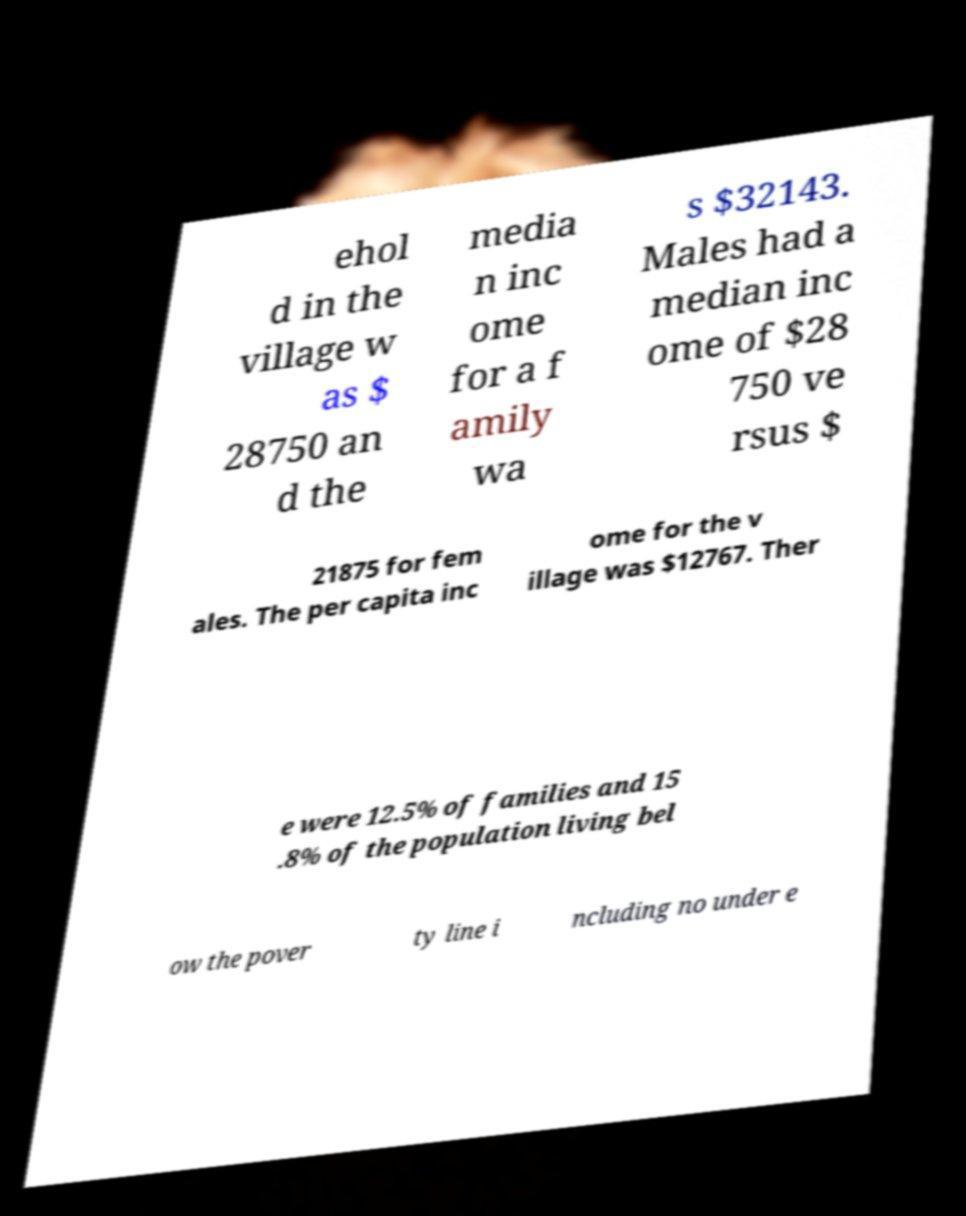There's text embedded in this image that I need extracted. Can you transcribe it verbatim? ehol d in the village w as $ 28750 an d the media n inc ome for a f amily wa s $32143. Males had a median inc ome of $28 750 ve rsus $ 21875 for fem ales. The per capita inc ome for the v illage was $12767. Ther e were 12.5% of families and 15 .8% of the population living bel ow the pover ty line i ncluding no under e 